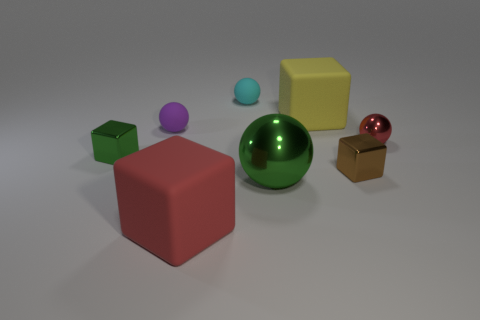Subtract all small purple rubber spheres. How many spheres are left? 3 Subtract all purple spheres. How many spheres are left? 3 Add 1 big green metal cylinders. How many objects exist? 9 Subtract 0 blue cylinders. How many objects are left? 8 Subtract 4 blocks. How many blocks are left? 0 Subtract all purple spheres. Subtract all red cylinders. How many spheres are left? 3 Subtract all large yellow metal cylinders. Subtract all cubes. How many objects are left? 4 Add 8 tiny purple balls. How many tiny purple balls are left? 9 Add 5 green shiny blocks. How many green shiny blocks exist? 6 